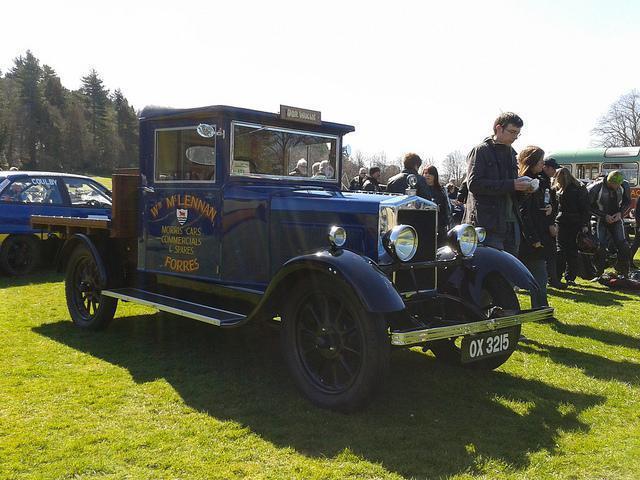What type of truck is shown?
Select the correct answer and articulate reasoning with the following format: 'Answer: answer
Rationale: rationale.'
Options: Moving, garbage, commercial, antique. Answer: antique.
Rationale: The truck is an antique. 